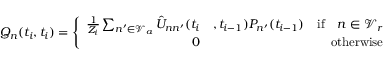<formula> <loc_0><loc_0><loc_500><loc_500>Q _ { n } ( t _ { i } , t _ { i } ) = \left \{ \begin{array} { r l r } { \frac { 1 } { Z _ { i } } \sum _ { n ^ { \prime } \in \mathcal { V } _ { a } } \hat { U } _ { n n ^ { \prime } } ( t _ { i } } & { , t _ { i - 1 } ) P _ { n ^ { \prime } } ( t _ { i - 1 } ) } & { i f \quad n \in \mathcal { V } _ { r } } \\ { 0 } & { o t h e r w i s e } \end{array}</formula> 